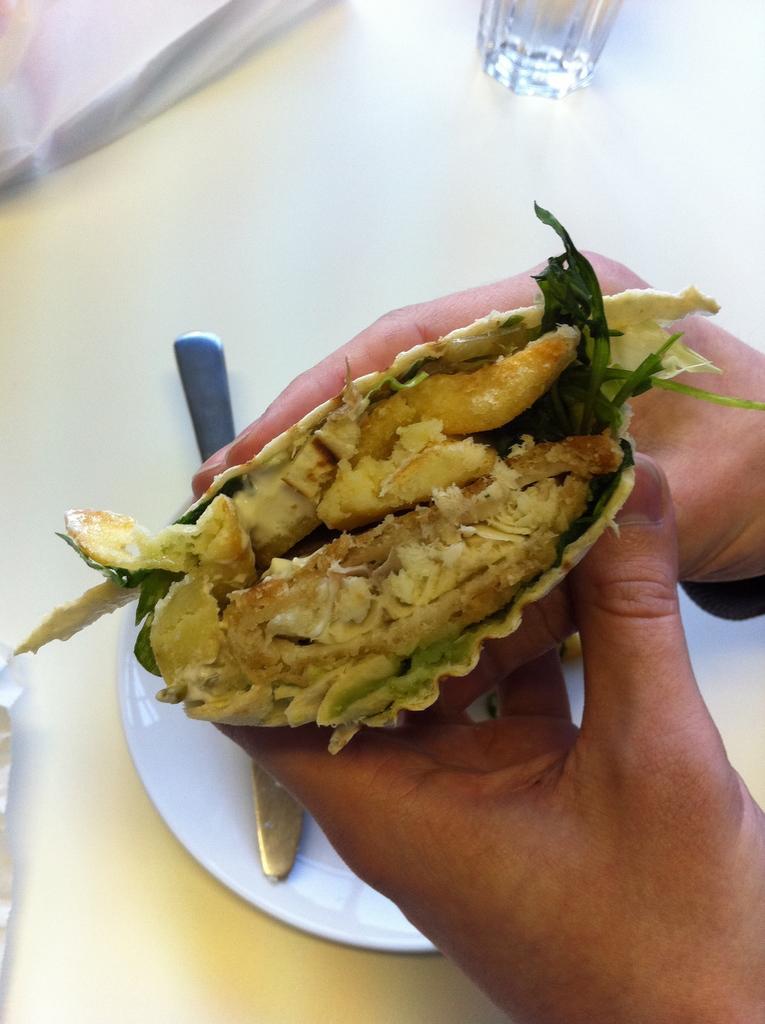Can you describe this image briefly? In this image we can see the hands of a person holding some food. On the backside we can see a knife in a plate, cover and a glass placed on the surface. 